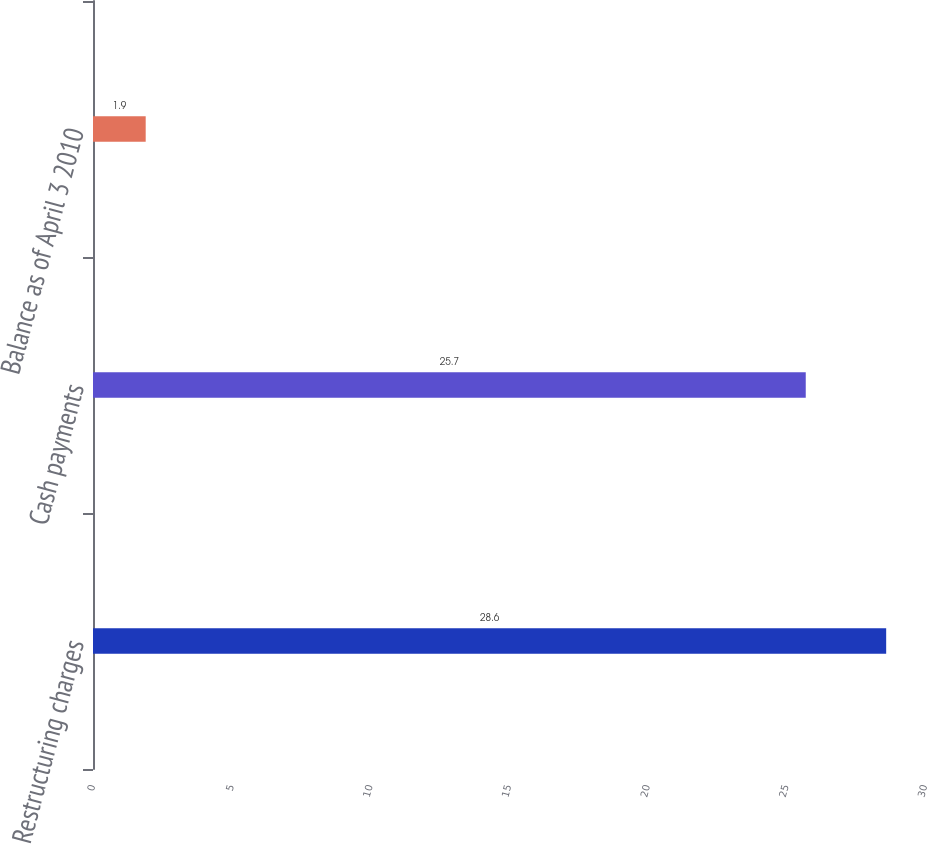Convert chart. <chart><loc_0><loc_0><loc_500><loc_500><bar_chart><fcel>Restructuring charges<fcel>Cash payments<fcel>Balance as of April 3 2010<nl><fcel>28.6<fcel>25.7<fcel>1.9<nl></chart> 